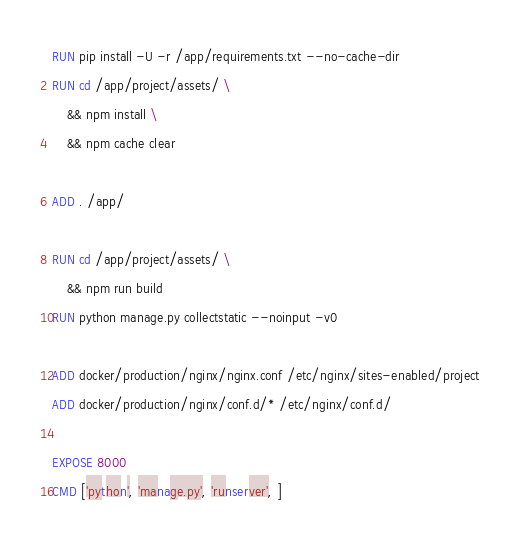Convert code to text. <code><loc_0><loc_0><loc_500><loc_500><_Dockerfile_>RUN pip install -U -r /app/requirements.txt --no-cache-dir
RUN cd /app/project/assets/ \
    && npm install \
    && npm cache clear

ADD . /app/

RUN cd /app/project/assets/ \
    && npm run build
RUN python manage.py collectstatic --noinput -v0

ADD docker/production/nginx/nginx.conf /etc/nginx/sites-enabled/project
ADD docker/production/nginx/conf.d/* /etc/nginx/conf.d/

EXPOSE 8000
CMD ['python', 'manage.py', 'runserver', ]
</code> 